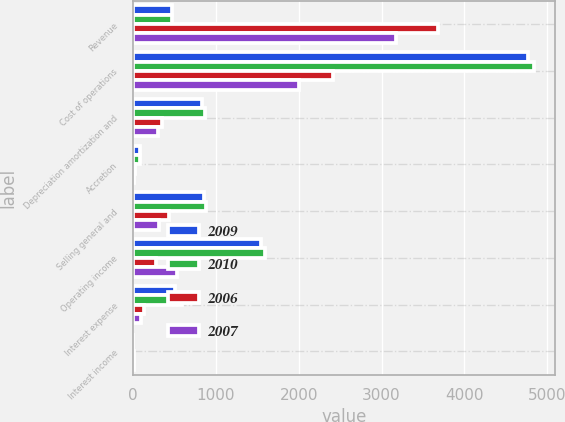Convert chart. <chart><loc_0><loc_0><loc_500><loc_500><stacked_bar_chart><ecel><fcel>Revenue<fcel>Cost of operations<fcel>Depreciation amortization and<fcel>Accretion<fcel>Selling general and<fcel>Operating income<fcel>Interest expense<fcel>Interest income<nl><fcel>2009<fcel>471.05<fcel>4764.8<fcel>833.7<fcel>80.5<fcel>858<fcel>1539.1<fcel>507.4<fcel>0.7<nl><fcel>2010<fcel>471.05<fcel>4844.2<fcel>869.7<fcel>88.8<fcel>880.4<fcel>1589.8<fcel>595.9<fcel>2<nl><fcel>2006<fcel>3685.1<fcel>2416.7<fcel>354.1<fcel>23.9<fcel>434.7<fcel>283.2<fcel>131.9<fcel>9.6<nl><fcel>2007<fcel>3176.2<fcel>2003.9<fcel>305.5<fcel>17.1<fcel>313.7<fcel>536<fcel>94.8<fcel>12.8<nl></chart> 